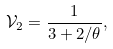Convert formula to latex. <formula><loc_0><loc_0><loc_500><loc_500>\mathcal { V } _ { 2 } = \frac { 1 } { 3 + 2 / \theta } ,</formula> 